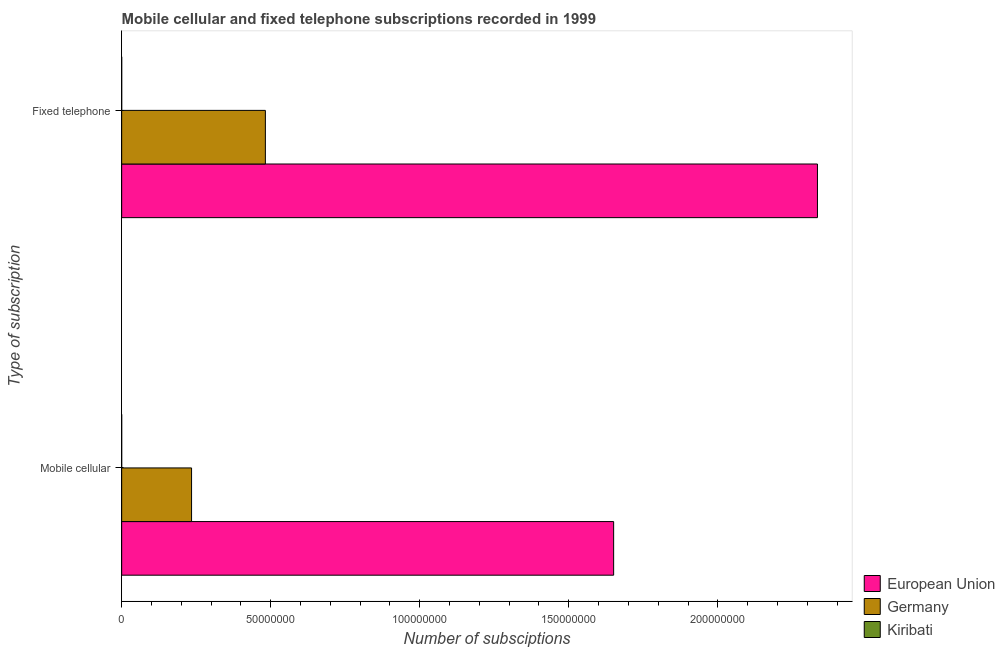How many different coloured bars are there?
Keep it short and to the point. 3. Are the number of bars per tick equal to the number of legend labels?
Offer a terse response. Yes. Are the number of bars on each tick of the Y-axis equal?
Offer a terse response. Yes. How many bars are there on the 1st tick from the top?
Your response must be concise. 3. How many bars are there on the 2nd tick from the bottom?
Keep it short and to the point. 3. What is the label of the 1st group of bars from the top?
Your answer should be compact. Fixed telephone. What is the number of mobile cellular subscriptions in European Union?
Make the answer very short. 1.65e+08. Across all countries, what is the maximum number of fixed telephone subscriptions?
Offer a very short reply. 2.33e+08. Across all countries, what is the minimum number of fixed telephone subscriptions?
Give a very brief answer. 3082. In which country was the number of fixed telephone subscriptions minimum?
Your answer should be very brief. Kiribati. What is the total number of fixed telephone subscriptions in the graph?
Your answer should be very brief. 2.82e+08. What is the difference between the number of mobile cellular subscriptions in European Union and that in Germany?
Keep it short and to the point. 1.42e+08. What is the difference between the number of mobile cellular subscriptions in Germany and the number of fixed telephone subscriptions in Kiribati?
Give a very brief answer. 2.34e+07. What is the average number of fixed telephone subscriptions per country?
Your response must be concise. 9.39e+07. What is the difference between the number of fixed telephone subscriptions and number of mobile cellular subscriptions in Germany?
Your answer should be very brief. 2.48e+07. What is the ratio of the number of mobile cellular subscriptions in European Union to that in Kiribati?
Keep it short and to the point. 8.25e+05. Is the number of mobile cellular subscriptions in Germany less than that in Kiribati?
Your answer should be compact. No. How many countries are there in the graph?
Keep it short and to the point. 3. Are the values on the major ticks of X-axis written in scientific E-notation?
Provide a short and direct response. No. Where does the legend appear in the graph?
Your answer should be very brief. Bottom right. What is the title of the graph?
Offer a terse response. Mobile cellular and fixed telephone subscriptions recorded in 1999. Does "Andorra" appear as one of the legend labels in the graph?
Provide a succinct answer. No. What is the label or title of the X-axis?
Provide a succinct answer. Number of subsciptions. What is the label or title of the Y-axis?
Offer a terse response. Type of subscription. What is the Number of subsciptions of European Union in Mobile cellular?
Offer a very short reply. 1.65e+08. What is the Number of subsciptions in Germany in Mobile cellular?
Your response must be concise. 2.34e+07. What is the Number of subsciptions in Kiribati in Mobile cellular?
Offer a very short reply. 200. What is the Number of subsciptions in European Union in Fixed telephone?
Your response must be concise. 2.33e+08. What is the Number of subsciptions in Germany in Fixed telephone?
Offer a terse response. 4.82e+07. What is the Number of subsciptions in Kiribati in Fixed telephone?
Keep it short and to the point. 3082. Across all Type of subscription, what is the maximum Number of subsciptions in European Union?
Offer a terse response. 2.33e+08. Across all Type of subscription, what is the maximum Number of subsciptions of Germany?
Your answer should be compact. 4.82e+07. Across all Type of subscription, what is the maximum Number of subsciptions of Kiribati?
Offer a very short reply. 3082. Across all Type of subscription, what is the minimum Number of subsciptions of European Union?
Provide a succinct answer. 1.65e+08. Across all Type of subscription, what is the minimum Number of subsciptions in Germany?
Ensure brevity in your answer.  2.34e+07. Across all Type of subscription, what is the minimum Number of subsciptions of Kiribati?
Give a very brief answer. 200. What is the total Number of subsciptions in European Union in the graph?
Offer a very short reply. 3.98e+08. What is the total Number of subsciptions in Germany in the graph?
Provide a short and direct response. 7.17e+07. What is the total Number of subsciptions in Kiribati in the graph?
Ensure brevity in your answer.  3282. What is the difference between the Number of subsciptions in European Union in Mobile cellular and that in Fixed telephone?
Provide a succinct answer. -6.84e+07. What is the difference between the Number of subsciptions in Germany in Mobile cellular and that in Fixed telephone?
Give a very brief answer. -2.48e+07. What is the difference between the Number of subsciptions in Kiribati in Mobile cellular and that in Fixed telephone?
Give a very brief answer. -2882. What is the difference between the Number of subsciptions in European Union in Mobile cellular and the Number of subsciptions in Germany in Fixed telephone?
Offer a terse response. 1.17e+08. What is the difference between the Number of subsciptions of European Union in Mobile cellular and the Number of subsciptions of Kiribati in Fixed telephone?
Keep it short and to the point. 1.65e+08. What is the difference between the Number of subsciptions in Germany in Mobile cellular and the Number of subsciptions in Kiribati in Fixed telephone?
Give a very brief answer. 2.34e+07. What is the average Number of subsciptions of European Union per Type of subscription?
Offer a terse response. 1.99e+08. What is the average Number of subsciptions of Germany per Type of subscription?
Offer a terse response. 3.58e+07. What is the average Number of subsciptions in Kiribati per Type of subscription?
Provide a succinct answer. 1641. What is the difference between the Number of subsciptions in European Union and Number of subsciptions in Germany in Mobile cellular?
Provide a succinct answer. 1.42e+08. What is the difference between the Number of subsciptions of European Union and Number of subsciptions of Kiribati in Mobile cellular?
Your answer should be compact. 1.65e+08. What is the difference between the Number of subsciptions in Germany and Number of subsciptions in Kiribati in Mobile cellular?
Give a very brief answer. 2.34e+07. What is the difference between the Number of subsciptions of European Union and Number of subsciptions of Germany in Fixed telephone?
Give a very brief answer. 1.85e+08. What is the difference between the Number of subsciptions of European Union and Number of subsciptions of Kiribati in Fixed telephone?
Your response must be concise. 2.33e+08. What is the difference between the Number of subsciptions of Germany and Number of subsciptions of Kiribati in Fixed telephone?
Make the answer very short. 4.82e+07. What is the ratio of the Number of subsciptions in European Union in Mobile cellular to that in Fixed telephone?
Offer a terse response. 0.71. What is the ratio of the Number of subsciptions in Germany in Mobile cellular to that in Fixed telephone?
Give a very brief answer. 0.49. What is the ratio of the Number of subsciptions in Kiribati in Mobile cellular to that in Fixed telephone?
Ensure brevity in your answer.  0.06. What is the difference between the highest and the second highest Number of subsciptions of European Union?
Your response must be concise. 6.84e+07. What is the difference between the highest and the second highest Number of subsciptions in Germany?
Provide a succinct answer. 2.48e+07. What is the difference between the highest and the second highest Number of subsciptions of Kiribati?
Keep it short and to the point. 2882. What is the difference between the highest and the lowest Number of subsciptions of European Union?
Give a very brief answer. 6.84e+07. What is the difference between the highest and the lowest Number of subsciptions of Germany?
Offer a very short reply. 2.48e+07. What is the difference between the highest and the lowest Number of subsciptions of Kiribati?
Offer a terse response. 2882. 